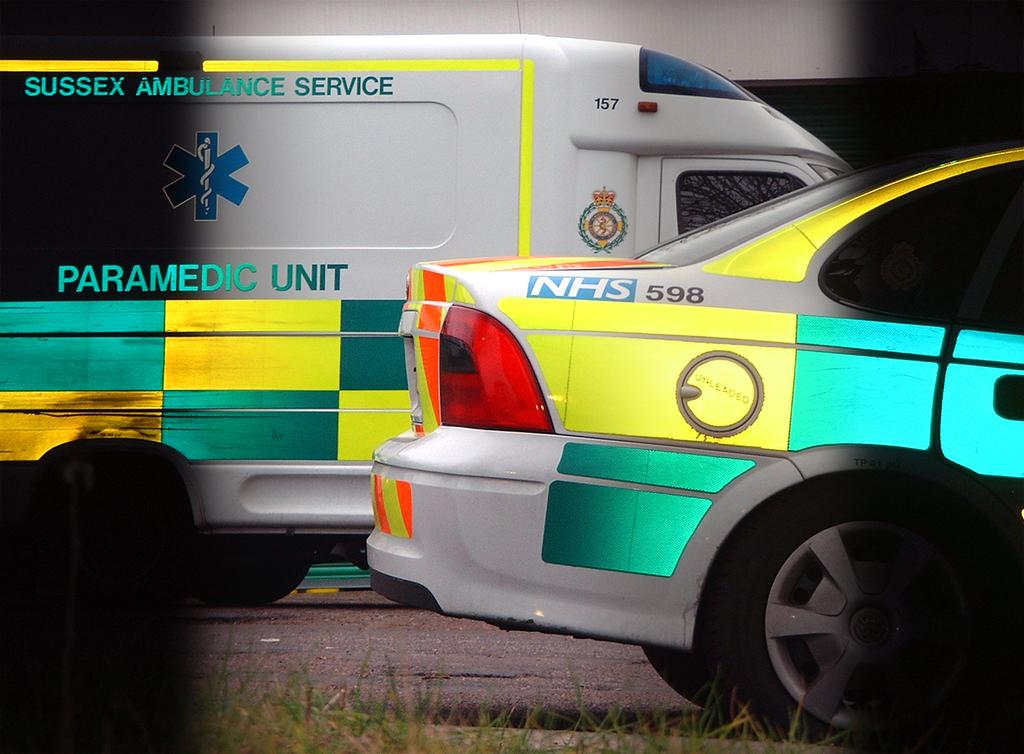What type of vehicles can you see?
Offer a very short reply. Ambulance. What numbers are these vehicles?
Offer a very short reply. 598. 